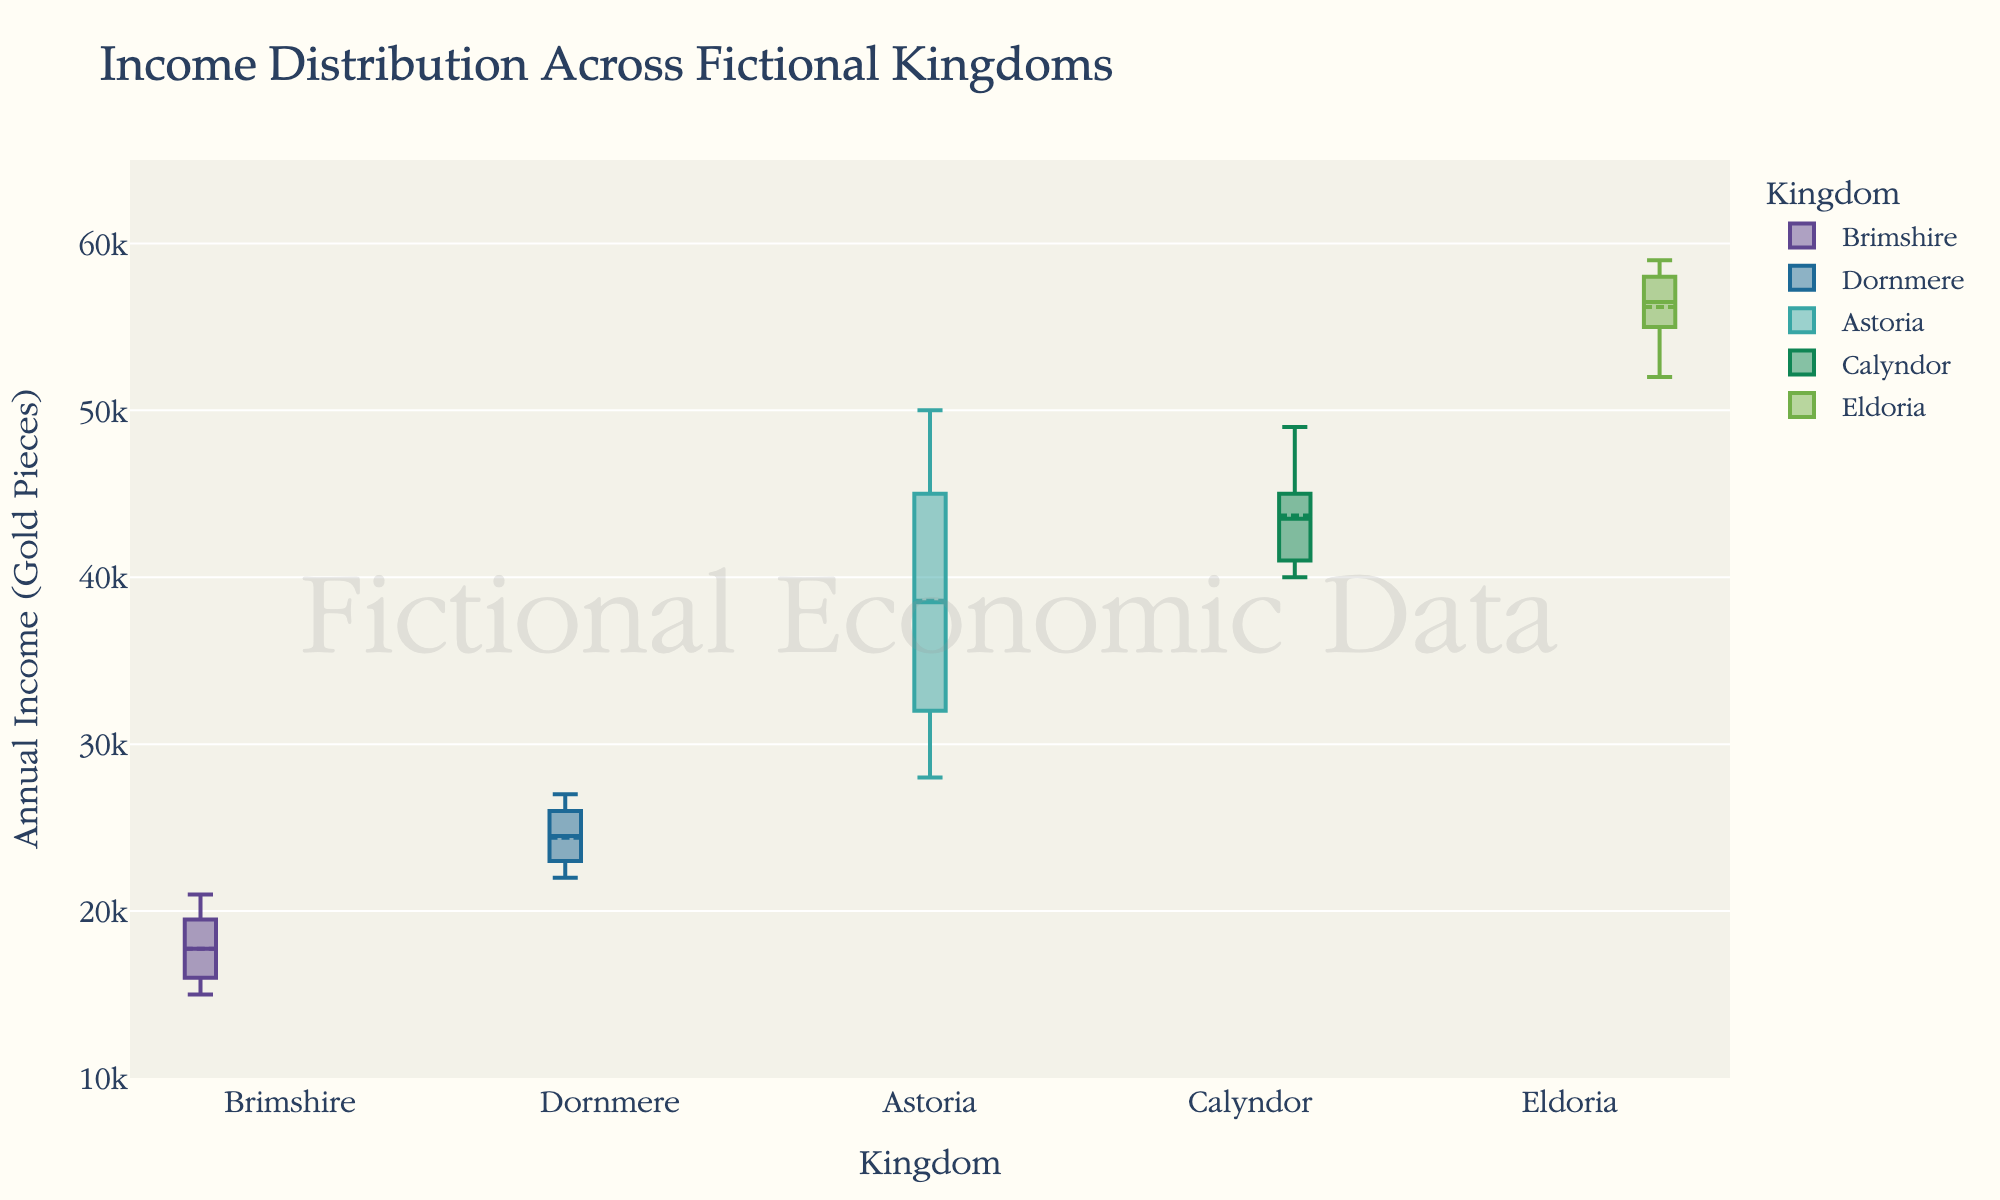What is the title of the figure? The title is usually displayed prominently at the top of the figure. For this box plot, it is "Income Distribution Across Fictional Kingdoms".
Answer: Income Distribution Across Fictional Kingdoms Which kingdom has the highest median income? In a box plot, the median is indicated by the line inside the central box. By comparing the medians, Eldoria has the highest median income.
Answer: Eldoria What is the range of income for Brimshire? The range is determined by the difference between the highest and lowest values. For Brimshire, this is 21000 (highest) - 15000 (lowest).
Answer: 6000 Which kingdom has the largest interquartile range (IQR)? The IQR is the length of the box in the box plot, showing the middle 50% of the data. By comparing boxes, Astoria has the largest IQR.
Answer: Astoria How does the median income of Dornmere compare to that of Astoria? The median is the line inside the box. Dornmere's median income is lower than Astoria’s.
Answer: Dornmere's median is lower Which kingdom shows the most variance in income distribution? Variance can be inferred from the spread and length of the whiskers. Astoria displays the highest variance as it has the longest whiskers.
Answer: Astoria Which two kingdoms have the closest median incomes? By examining the medians represented by the horizontal lines in the boxes, Calyndor and Eldoria have very close median incomes.
Answer: Calyndor and Eldoria What is the mean income in Eldoria as indicated in the plot? The mean is marked by a distinct symbol (often a dot) within the box plot. This symbol should be identified in Eldoria’s box.
Answer: Between 55000 and 56000 How does the whisker length of Brimshire compare to that of Calyndor? Whisker length indicates the spread of the data. Brimshire’s whiskers are shorter compared to Calyndor.
Answer: Brimshire's whiskers are shorter Which kingdom has the smallest overall spread in its income distribution? The overall spread is indicated by the distance between the minimum and maximum values (whiskers). Brimshire has the smallest spread.
Answer: Brimshire 